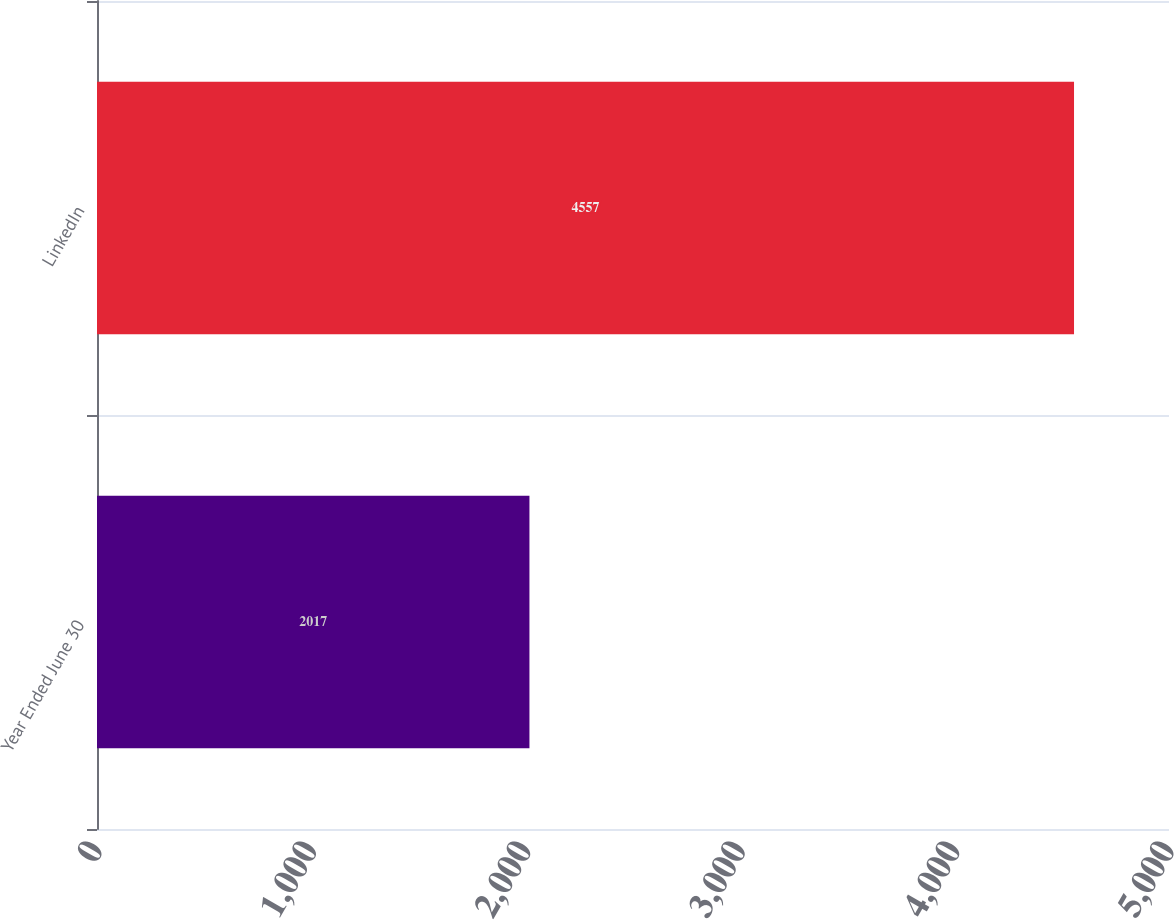Convert chart. <chart><loc_0><loc_0><loc_500><loc_500><bar_chart><fcel>Year Ended June 30<fcel>LinkedIn<nl><fcel>2017<fcel>4557<nl></chart> 